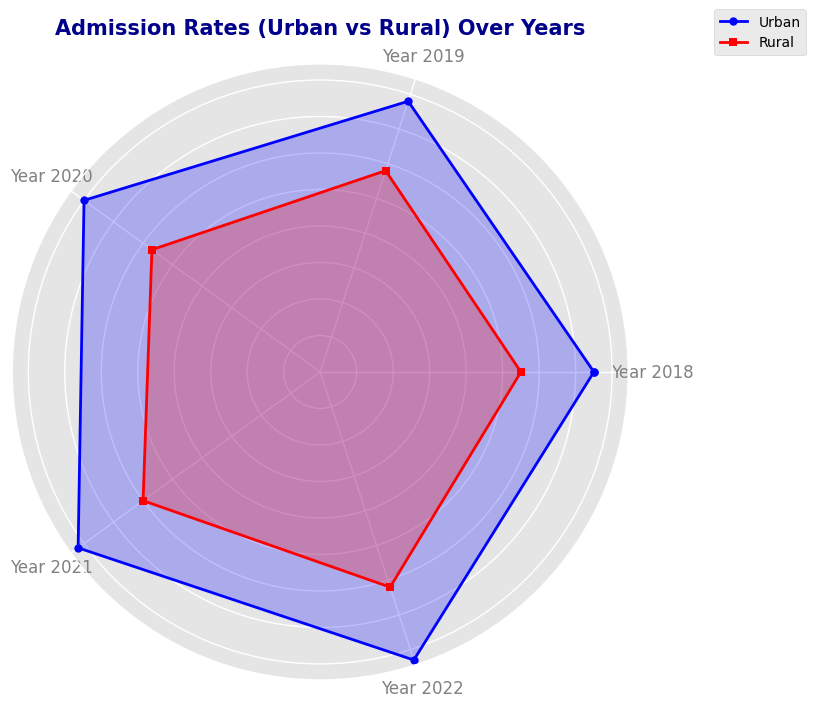What is the admission rate for urban students in the year 2020? The radar chart shows the admission rates of urban students for the years 2018 to 2022. Locate the year 2020 and follow the urban plot (blue line) to see the admission rate.
Answer: 80 What is the difference in admission rates between urban and rural students for the year 2019? Find the admission rates for both urban (blue line) and rural (red line) students in the year 2019 from the radar chart, then subtract the rural rate from the urban rate (78 - 58).
Answer: 20 Which area had a higher increase in admission rates from 2018 to 2022? Examine the admission rate growth from 2018 to 2022 for both areas. The urban area increased from 75 to 83 while the rural area increased from 55 to 62. Calculate the increase (8 for urban and 7 for rural) to determine which is higher.
Answer: Urban How does the admission rate for rural students in 2021 compare to urban students in 2021? Look for the admission rates of rural and urban students in 2021 on the radar chart. Compare the two values directly (rural: 60; urban: 82).
Answer: Lower What is the average admission rate of urban students from 2018 to 2022? Sum up the admission rates of urban students from 2018 to 2022 (75 + 78 + 80 + 82 + 83) and divide by the number of years (5). The calculation gives an average of 79.6.
Answer: 79.6 What is the difference between the highest and lowest admission rates for rural students? Determine the highest (62 in 2022) and lowest (55 in 2018) admission rates for rural students and subtract the lowest from the highest (62 - 55).
Answer: 7 Which year shows the smallest difference in admission rates between urban and rural students? Calculate the difference in each year by finding the absolute value of the difference between urban and rural rates. The differences are 20 (2018), 20 (2019), 23 (2020), 22 (2021), and 21 (2022). The smallest difference is in 2018 and 2019.
Answer: 2018 and 2019 How many more percentage points did urban students gain in admission rates compared to rural students from 2018 to 2022? Determine the total increase in admission rates from 2018 to 2022 for both urban (83 - 75 = 8) and rural (62 - 55 = 7). Subtract the rural increase from the urban increase (8 - 7).
Answer: 1 What visual difference separates the urban and rural admission rate plots the most on the radar chart? Analyze the visual plot to see that the urban (blue) and rural (red) admission rate lines diverge the most. The significant visual difference between the two areas' lines is in the rate intervals between 2018 and 2021.
Answer: The gap between the blue and red lines 